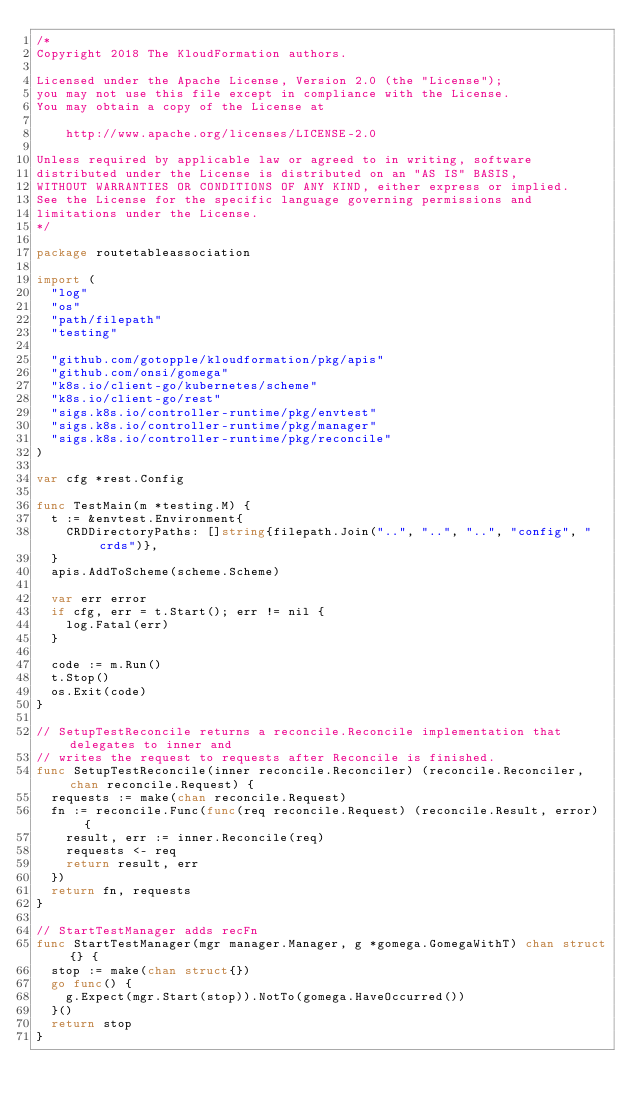<code> <loc_0><loc_0><loc_500><loc_500><_Go_>/*
Copyright 2018 The KloudFormation authors.

Licensed under the Apache License, Version 2.0 (the "License");
you may not use this file except in compliance with the License.
You may obtain a copy of the License at

    http://www.apache.org/licenses/LICENSE-2.0

Unless required by applicable law or agreed to in writing, software
distributed under the License is distributed on an "AS IS" BASIS,
WITHOUT WARRANTIES OR CONDITIONS OF ANY KIND, either express or implied.
See the License for the specific language governing permissions and
limitations under the License.
*/

package routetableassociation

import (
	"log"
	"os"
	"path/filepath"
	"testing"

	"github.com/gotopple/kloudformation/pkg/apis"
	"github.com/onsi/gomega"
	"k8s.io/client-go/kubernetes/scheme"
	"k8s.io/client-go/rest"
	"sigs.k8s.io/controller-runtime/pkg/envtest"
	"sigs.k8s.io/controller-runtime/pkg/manager"
	"sigs.k8s.io/controller-runtime/pkg/reconcile"
)

var cfg *rest.Config

func TestMain(m *testing.M) {
	t := &envtest.Environment{
		CRDDirectoryPaths: []string{filepath.Join("..", "..", "..", "config", "crds")},
	}
	apis.AddToScheme(scheme.Scheme)

	var err error
	if cfg, err = t.Start(); err != nil {
		log.Fatal(err)
	}

	code := m.Run()
	t.Stop()
	os.Exit(code)
}

// SetupTestReconcile returns a reconcile.Reconcile implementation that delegates to inner and
// writes the request to requests after Reconcile is finished.
func SetupTestReconcile(inner reconcile.Reconciler) (reconcile.Reconciler, chan reconcile.Request) {
	requests := make(chan reconcile.Request)
	fn := reconcile.Func(func(req reconcile.Request) (reconcile.Result, error) {
		result, err := inner.Reconcile(req)
		requests <- req
		return result, err
	})
	return fn, requests
}

// StartTestManager adds recFn
func StartTestManager(mgr manager.Manager, g *gomega.GomegaWithT) chan struct{} {
	stop := make(chan struct{})
	go func() {
		g.Expect(mgr.Start(stop)).NotTo(gomega.HaveOccurred())
	}()
	return stop
}
</code> 